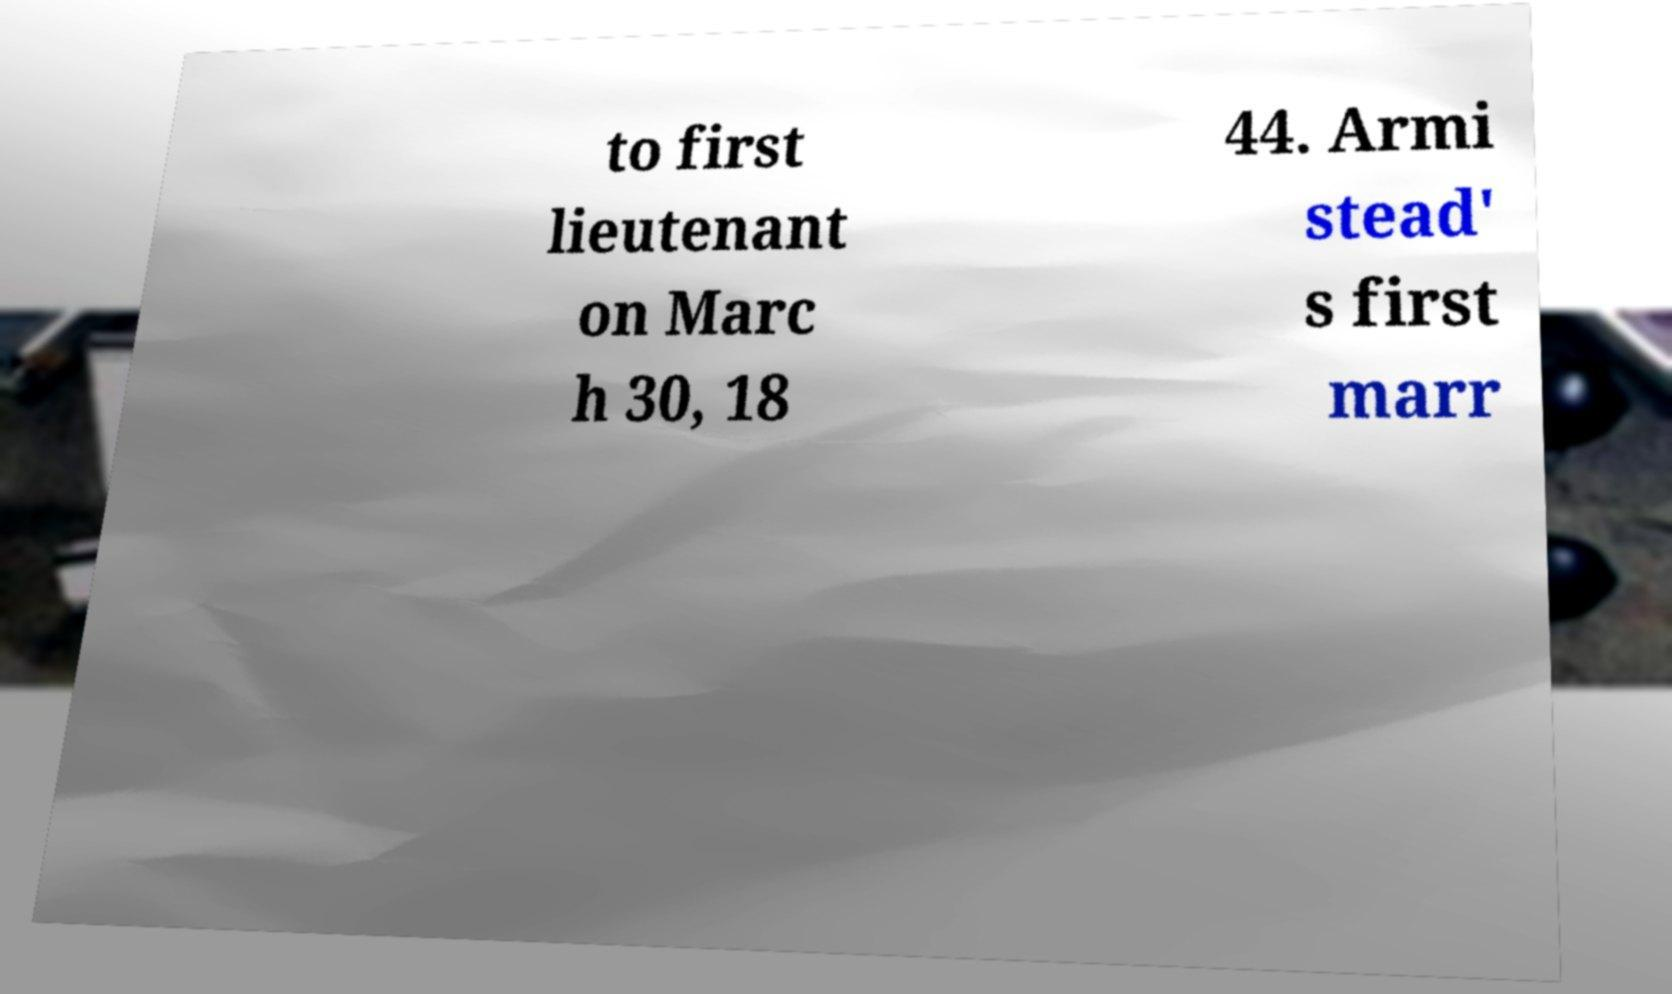There's text embedded in this image that I need extracted. Can you transcribe it verbatim? to first lieutenant on Marc h 30, 18 44. Armi stead' s first marr 